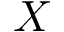<formula> <loc_0><loc_0><loc_500><loc_500>X</formula> 